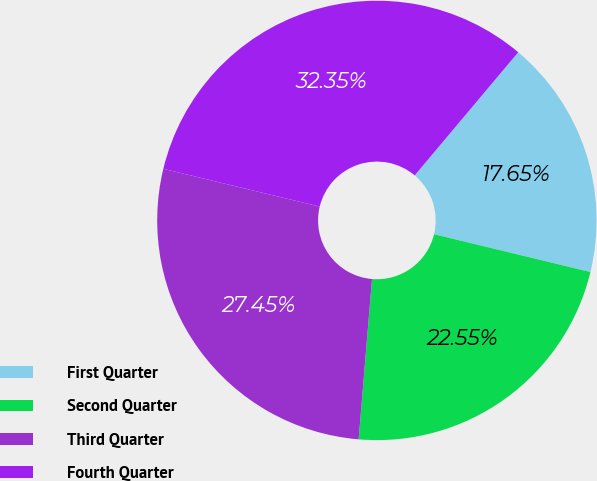Convert chart. <chart><loc_0><loc_0><loc_500><loc_500><pie_chart><fcel>First Quarter<fcel>Second Quarter<fcel>Third Quarter<fcel>Fourth Quarter<nl><fcel>17.65%<fcel>22.55%<fcel>27.45%<fcel>32.35%<nl></chart> 